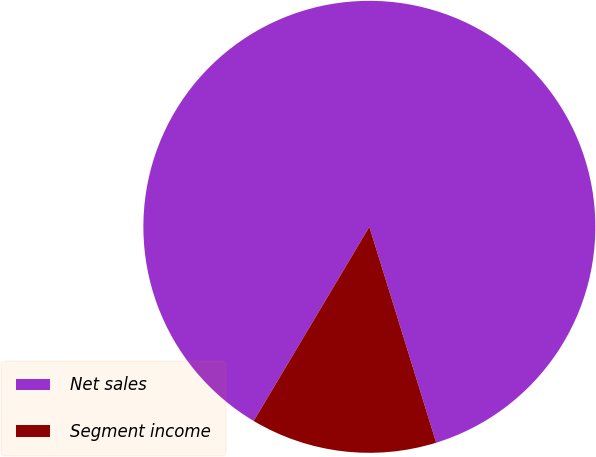<chart> <loc_0><loc_0><loc_500><loc_500><pie_chart><fcel>Net sales<fcel>Segment income<nl><fcel>86.67%<fcel>13.33%<nl></chart> 